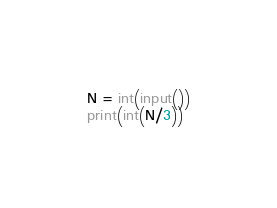Convert code to text. <code><loc_0><loc_0><loc_500><loc_500><_Python_>N = int(input())
print(int(N/3))</code> 